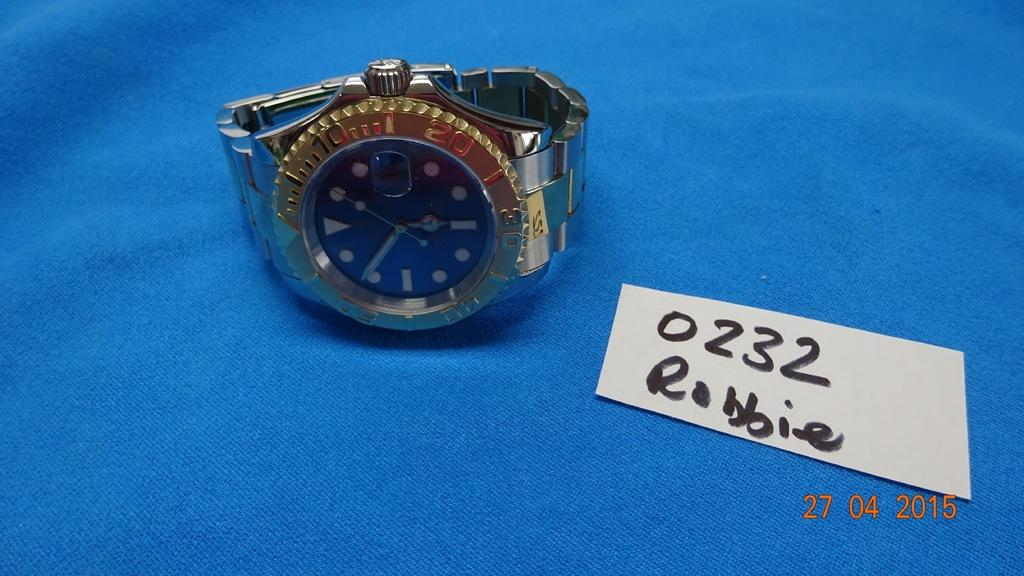<image>
Render a clear and concise summary of the photo. A silver and gold watch that is owned by Robbie. 